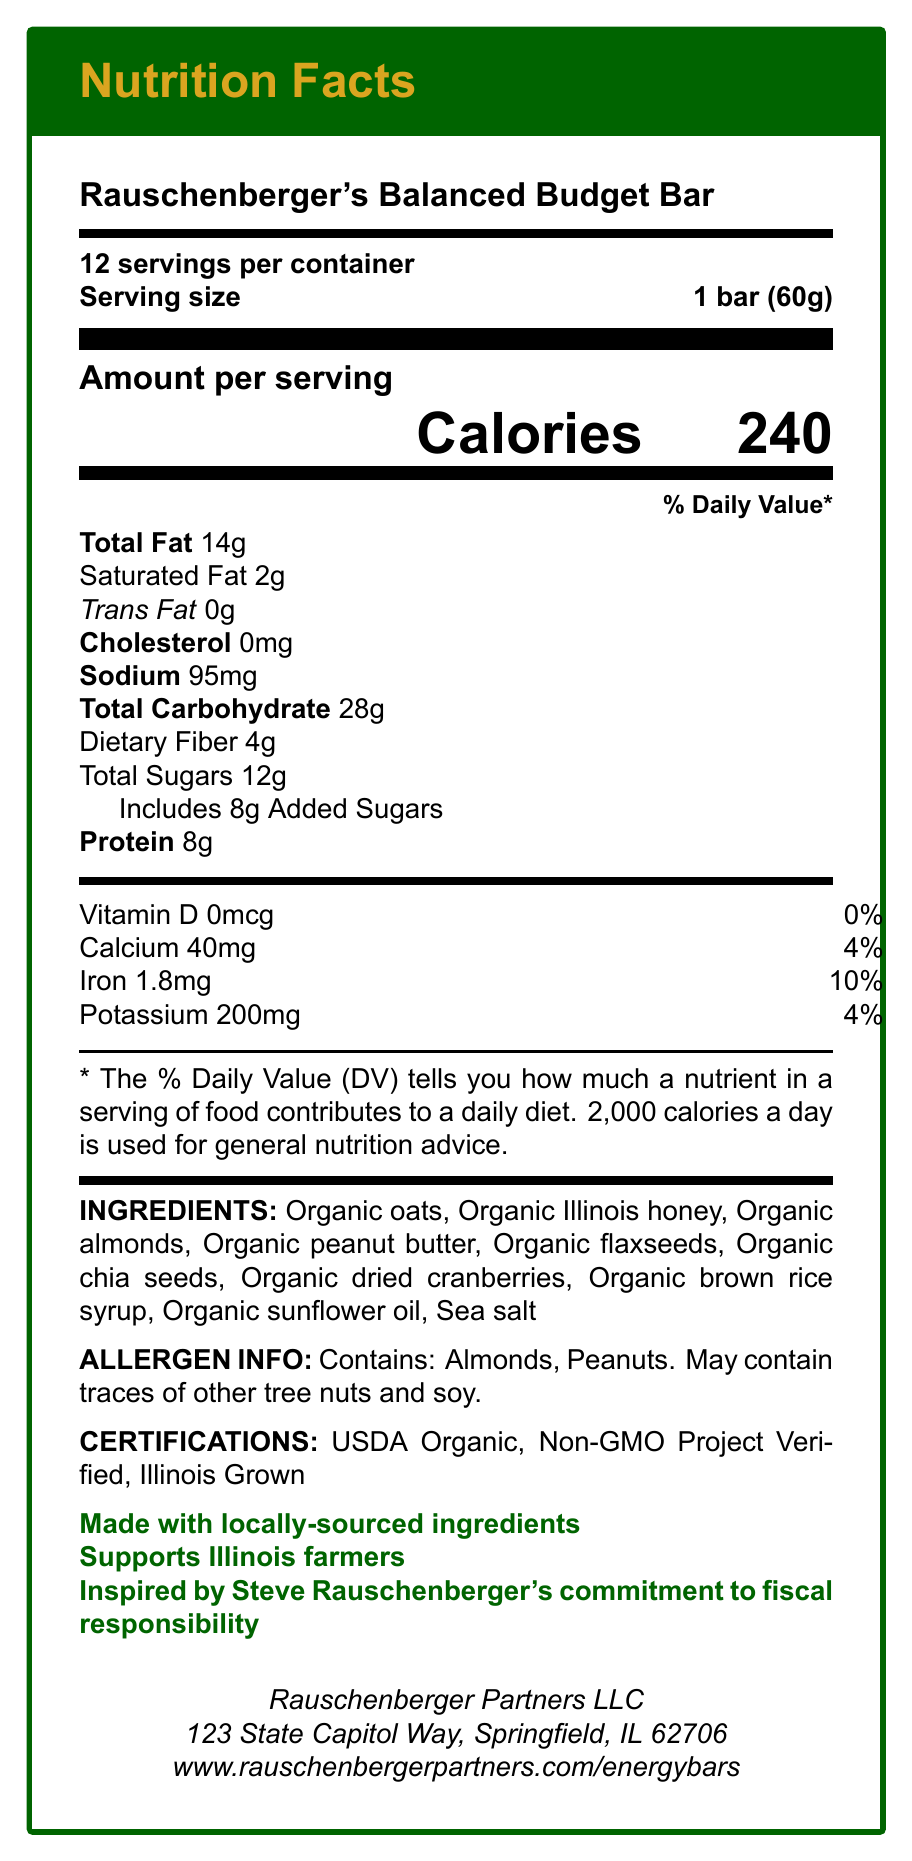what is the serving size for Rauschenberger's Balanced Budget Bar? The serving size is listed at the top of the Nutrition Facts section as "Serving size 1 bar (60g)".
Answer: 1 bar (60g) how many servings are in one container? The label states at the top "12 servings per container".
Answer: 12 what is the calorie content per serving? "Calories 240" is prominently displayed under the "Amount per serving" section.
Answer: 240 what is the total fat content in a single serving of the bar? The Total Fat content is listed as "Total Fat 14g" under the % Daily Value table.
Answer: 14g how much dietary fiber does one bar contain? Dietary Fiber is listed as "Dietary Fiber 4g" under the Total Carbohydrate section.
Answer: 4g what certifications does Rauschenberger's Balanced Budget Bar have? The certifications are mentioned towards the bottom of the label under the "CERTIFICATIONS:" section.
Answer: USDA Organic, Non-GMO Project Verified, Illinois Grown which of the following is NOT an ingredient in Rauschenberger's Balanced Budget Bar? A. Organic oats B. Organic honey C. Organic quinoa D. Organic almonds The list of ingredients does not include organic quinoa; it includes organic oats, organic honey (specifically Illinois honey), and organic almonds.
Answer: C. Organic quinoa how much protein does each bar have? A. 4g B. 6g C. 8g D. 10g The protein content is listed as "Protein 8g" in the table under Amount per serving.
Answer: C. 8g does the bar contain trans fats? The label states "Trans Fat 0g" indicating no trans fats in the bar.
Answer: No what information can be found about the certifications of the bar? The "CERTIFICATIONS:" section lists USDA Organic, Non-GMO Project Verified, and Illinois Grown.
Answer: The bar is certified as USDA Organic, Non-GMO Project Verified, Illinois Grown. summarize the document. The document provides comprehensive nutritional details and highlights the organic, locally-sourced nature of the energy bar, emphasizing support for local farmers and Rauschenberger's commitment to fiscal responsibility.
Answer: The document is a Nutrition Facts Label for "Rauschenberger's Balanced Budget Bar," detailing its nutritional information, ingredients, allergen information, certifications, and marketing claims. It highlights locally-sourced and organic ingredients, with a focus on supporting Illinois farmers, aligning with Steve Rauschenberger's values. The label includes the serving size, servings per container, calorie count, and percentage daily values for various nutrients. The document also provides contact information for Rauschenberger Partners LLC. how much sodium does each bar contain? The sodium content is listed as "Sodium 95mg" in the % Daily Value table.
Answer: 95mg does each bar contain any vitamin D? The document states "Vitamin D 0mcg 0%" indicating no vitamin D is present.
Answer: No which nutrient contributes 16% to the daily value per bar? Under the Total Carbohydrate section, it lists "Includes 8g Added Sugars 16%".
Answer: Added Sugars can the exact amount of dietary fiber in one serving be determined? It is clearly listed as "Dietary Fiber 4g" under the Total Carbohydrate section.
Answer: Yes what is Steve Rauschenberger's relation to the energy bar? The label mentions, "Inspired by Steve Rauschenberger's commitment to fiscal responsibility."
Answer: The bar is inspired by Steve Rauschenberger's commitment to fiscal responsibility. where is Rauschenberger Partners LLC located? The address is listed at the bottom of the Nutrition Facts section.
Answer: 123 State Capitol Way, Springfield, IL 62706 is the product made with locally-sourced ingredients? The label specifically claims "Made with locally-sourced ingredients".
Answer: Yes what is the total daily value percentage of iron per bar? A. 10% B. 4% C. 14% D. 18% The iron content is listed as "Iron 1.8mg 10%" in the vitamin and mineral section.
Answer: A. 10% what is the website for more information about the energy bars? The website is provided at the bottom of the document.
Answer: www.rauschenbergerpartners.com/energybars 